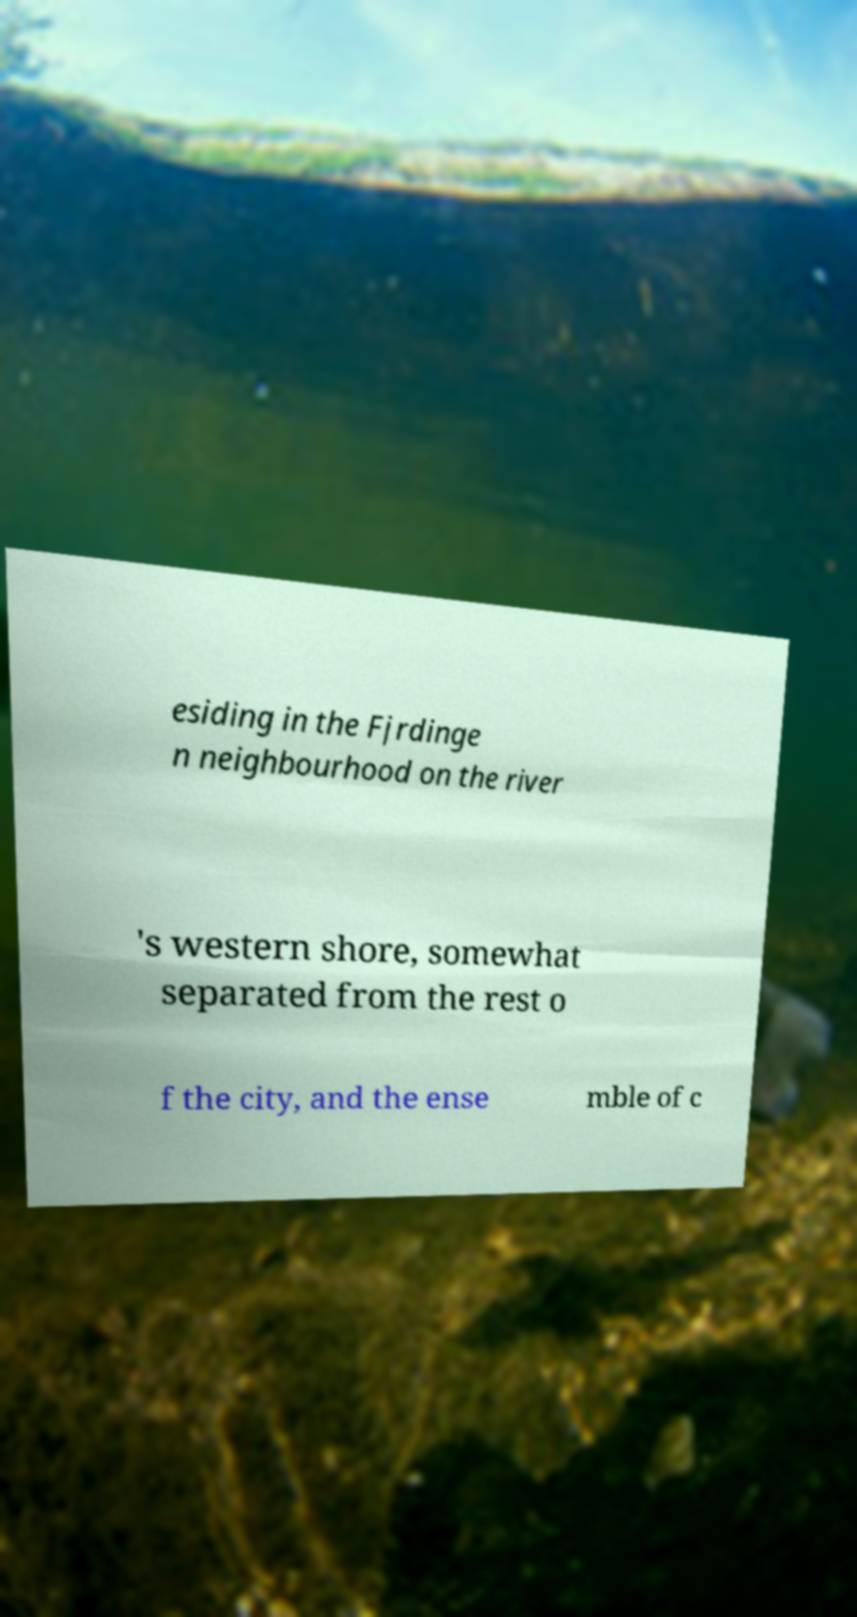There's text embedded in this image that I need extracted. Can you transcribe it verbatim? esiding in the Fjrdinge n neighbourhood on the river 's western shore, somewhat separated from the rest o f the city, and the ense mble of c 